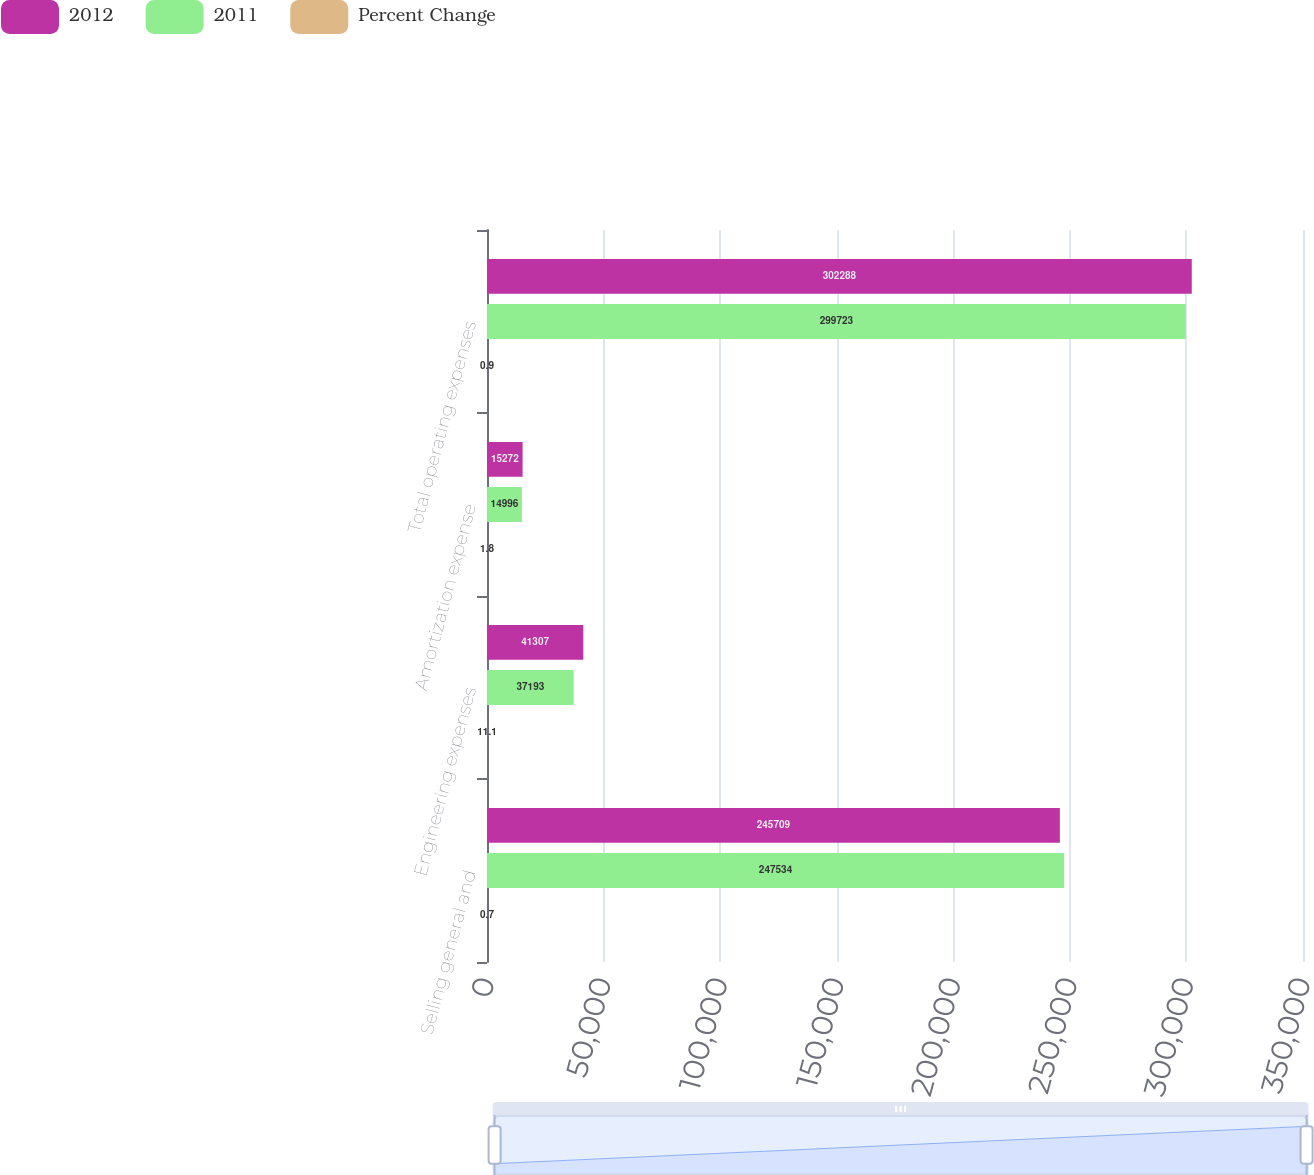Convert chart. <chart><loc_0><loc_0><loc_500><loc_500><stacked_bar_chart><ecel><fcel>Selling general and<fcel>Engineering expenses<fcel>Amortization expense<fcel>Total operating expenses<nl><fcel>2012<fcel>245709<fcel>41307<fcel>15272<fcel>302288<nl><fcel>2011<fcel>247534<fcel>37193<fcel>14996<fcel>299723<nl><fcel>Percent Change<fcel>0.7<fcel>11.1<fcel>1.8<fcel>0.9<nl></chart> 